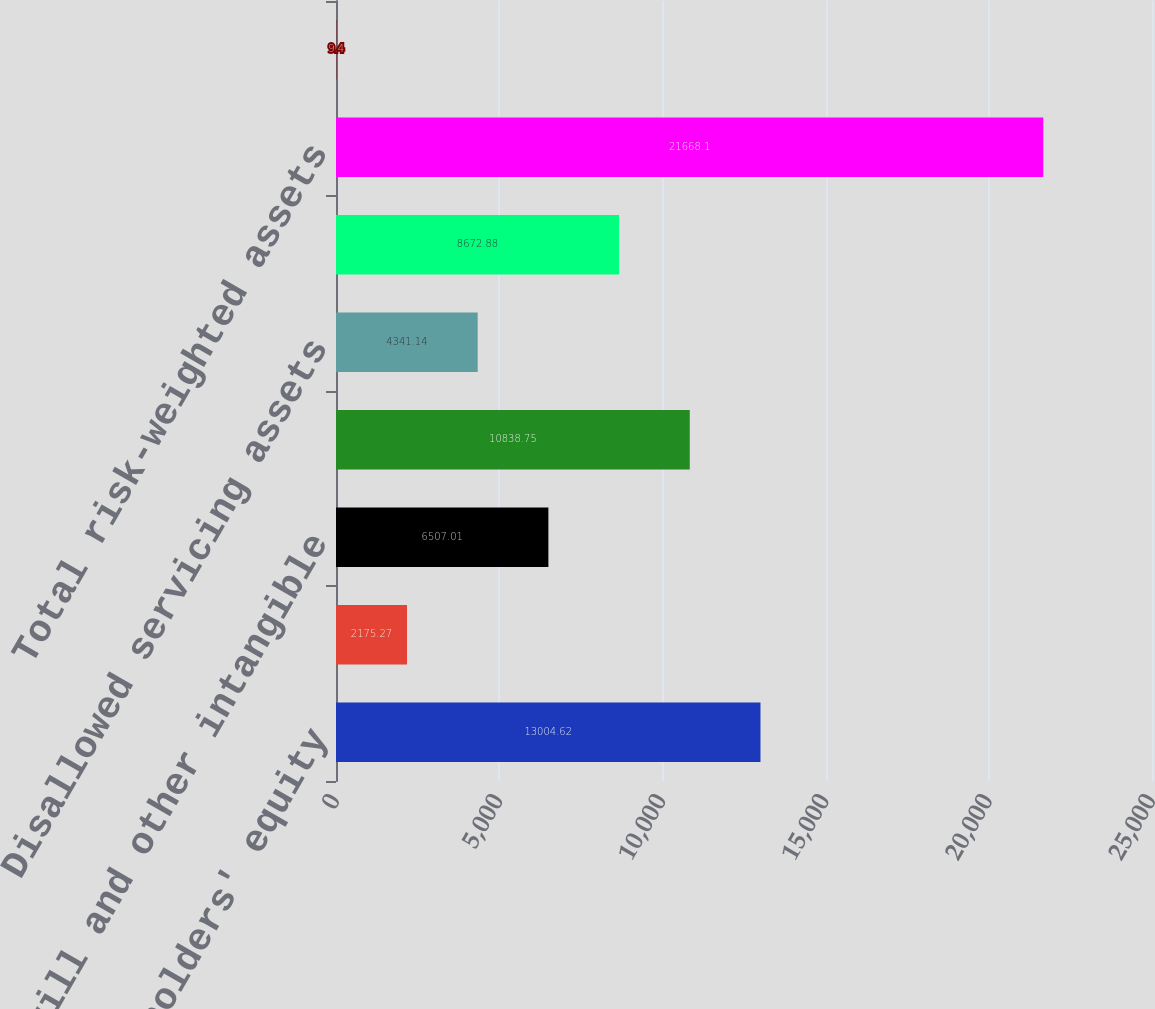Convert chart. <chart><loc_0><loc_0><loc_500><loc_500><bar_chart><fcel>Shareholders' equity<fcel>Losses in other comprehensive<fcel>Goodwill and other intangible<fcel>Subtotal<fcel>Disallowed servicing assets<fcel>Tier 1 common<fcel>Total risk-weighted assets<fcel>Tier 1 common ratio (Tier 1<nl><fcel>13004.6<fcel>2175.27<fcel>6507.01<fcel>10838.8<fcel>4341.14<fcel>8672.88<fcel>21668.1<fcel>9.4<nl></chart> 